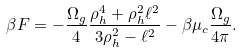<formula> <loc_0><loc_0><loc_500><loc_500>\beta F = - \frac { \Omega _ { g } } { 4 } \frac { \rho _ { h } ^ { 4 } + \rho _ { h } ^ { 2 } \ell ^ { 2 } } { 3 \rho _ { h } ^ { 2 } - \ell ^ { 2 } } - \beta \mu _ { c } \frac { \Omega _ { g } } { 4 \pi } .</formula> 